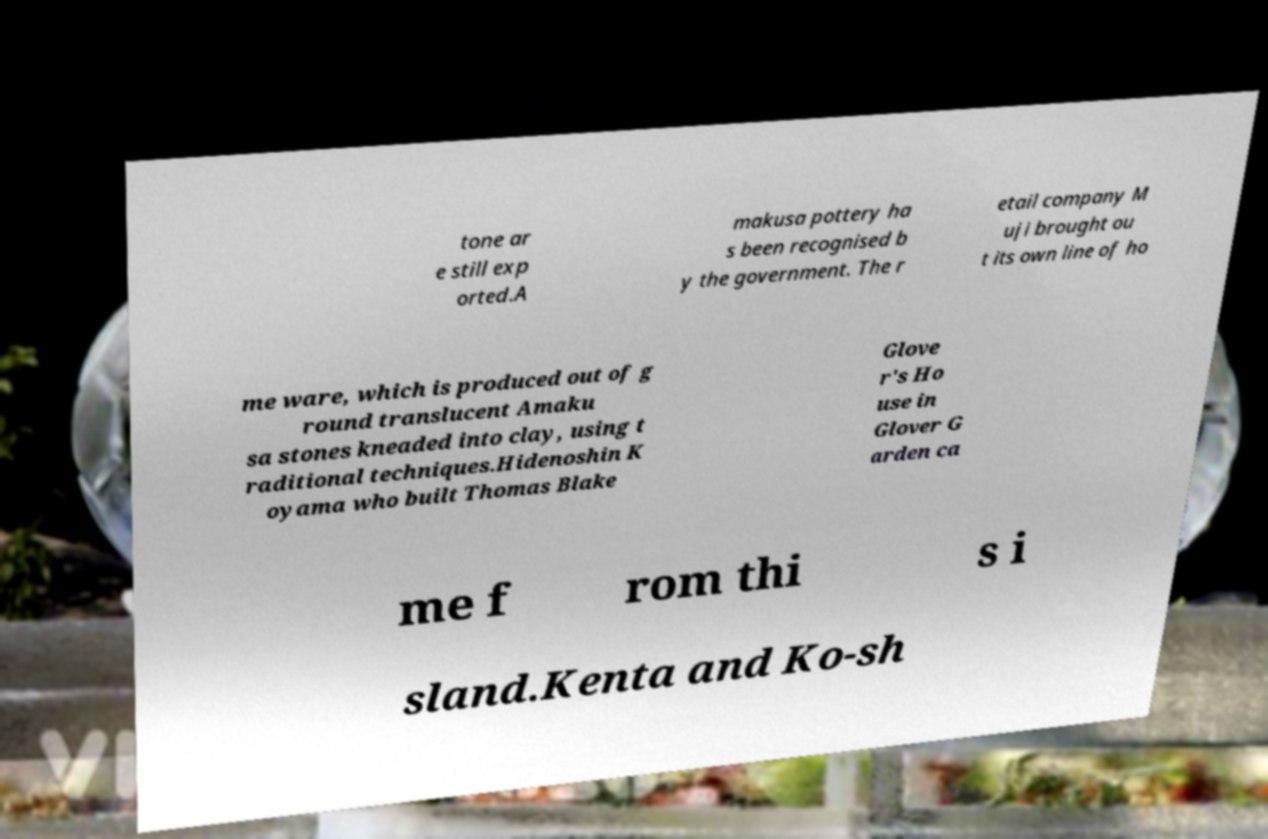Could you assist in decoding the text presented in this image and type it out clearly? tone ar e still exp orted.A makusa pottery ha s been recognised b y the government. The r etail company M uji brought ou t its own line of ho me ware, which is produced out of g round translucent Amaku sa stones kneaded into clay, using t raditional techniques.Hidenoshin K oyama who built Thomas Blake Glove r's Ho use in Glover G arden ca me f rom thi s i sland.Kenta and Ko-sh 